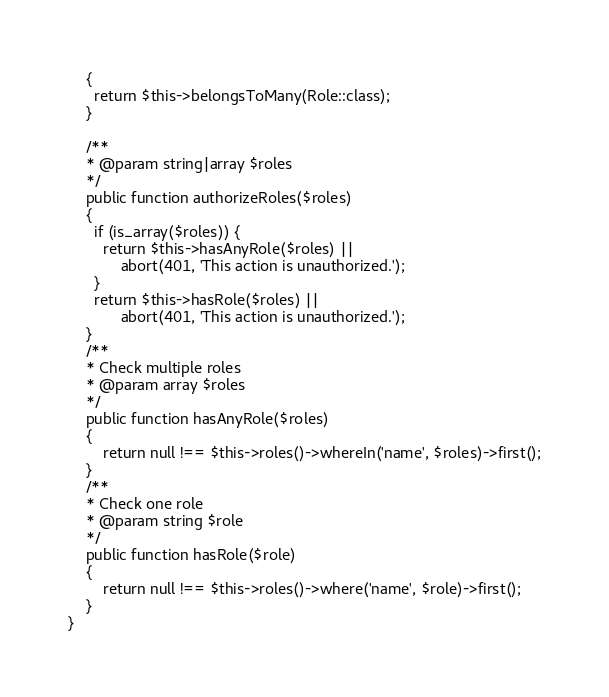Convert code to text. <code><loc_0><loc_0><loc_500><loc_500><_PHP_>    {
      return $this->belongsToMany(Role::class);
    }
    
    /**
    * @param string|array $roles
    */
    public function authorizeRoles($roles)
    {
      if (is_array($roles)) {
        return $this->hasAnyRole($roles) || 
            abort(401, 'This action is unauthorized.');
      }
      return $this->hasRole($roles) || 
            abort(401, 'This action is unauthorized.');
    }
    /**
    * Check multiple roles
    * @param array $roles
    */
    public function hasAnyRole($roles)
    {
        return null !== $this->roles()->whereIn('name', $roles)->first();
    }
    /**
    * Check one role
    * @param string $role
    */
    public function hasRole($role)
    {
        return null !== $this->roles()->where('name', $role)->first();
    }
}
</code> 